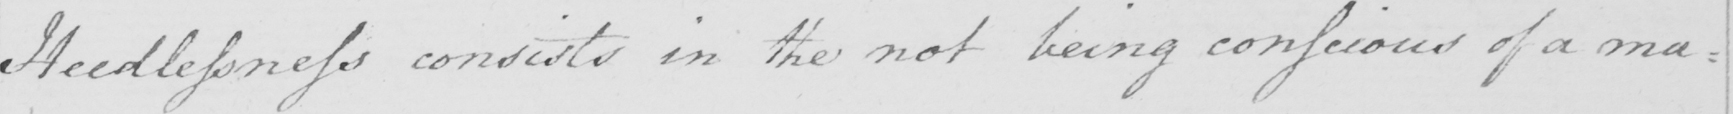Can you read and transcribe this handwriting? Heedlessness consists in the not being conscious of a ma= 